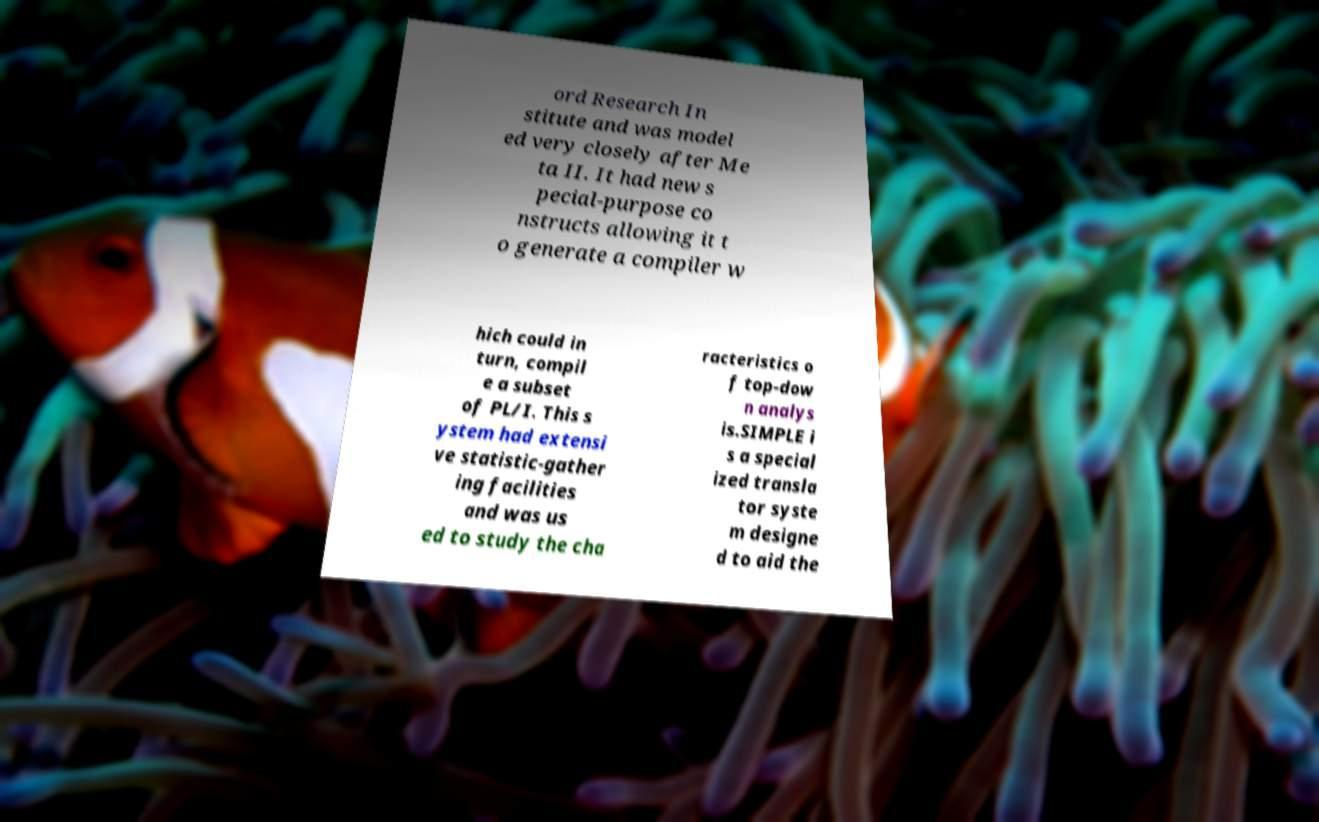Can you accurately transcribe the text from the provided image for me? ord Research In stitute and was model ed very closely after Me ta II. It had new s pecial-purpose co nstructs allowing it t o generate a compiler w hich could in turn, compil e a subset of PL/I. This s ystem had extensi ve statistic-gather ing facilities and was us ed to study the cha racteristics o f top-dow n analys is.SIMPLE i s a special ized transla tor syste m designe d to aid the 